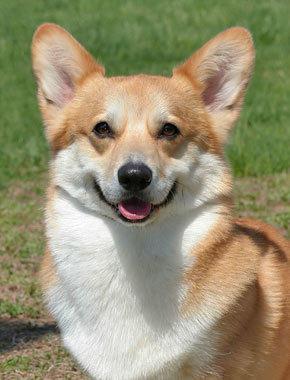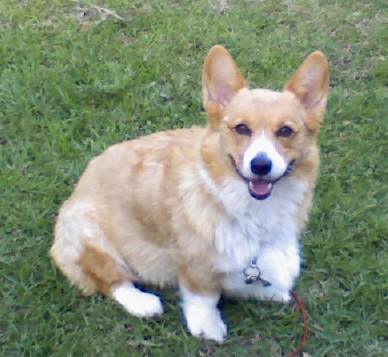The first image is the image on the left, the second image is the image on the right. Considering the images on both sides, is "Each image contains exactly one corgi dog, and no dog has its rear-end facing the camera." valid? Answer yes or no. Yes. The first image is the image on the left, the second image is the image on the right. Considering the images on both sides, is "At least one dog is sitting on its hind legs in the pair of images." valid? Answer yes or no. Yes. 